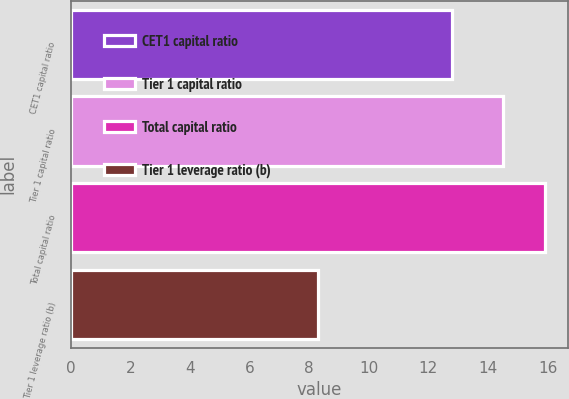<chart> <loc_0><loc_0><loc_500><loc_500><bar_chart><fcel>CET1 capital ratio<fcel>Tier 1 capital ratio<fcel>Total capital ratio<fcel>Tier 1 leverage ratio (b)<nl><fcel>12.8<fcel>14.5<fcel>15.9<fcel>8.3<nl></chart> 